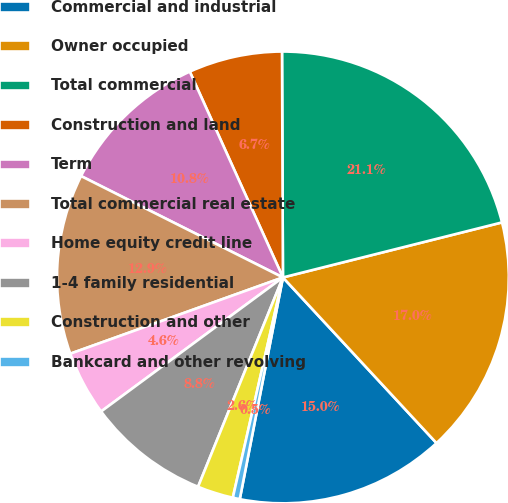Convert chart. <chart><loc_0><loc_0><loc_500><loc_500><pie_chart><fcel>Commercial and industrial<fcel>Owner occupied<fcel>Total commercial<fcel>Construction and land<fcel>Term<fcel>Total commercial real estate<fcel>Home equity credit line<fcel>1-4 family residential<fcel>Construction and other<fcel>Bankcard and other revolving<nl><fcel>14.96%<fcel>17.02%<fcel>21.15%<fcel>6.7%<fcel>10.83%<fcel>12.89%<fcel>4.63%<fcel>8.76%<fcel>2.57%<fcel>0.5%<nl></chart> 